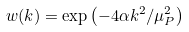Convert formula to latex. <formula><loc_0><loc_0><loc_500><loc_500>w ( k ) = \exp \left ( { - 4 \alpha { k ^ { 2 } } / { \mu ^ { 2 } _ { P } } } \right )</formula> 